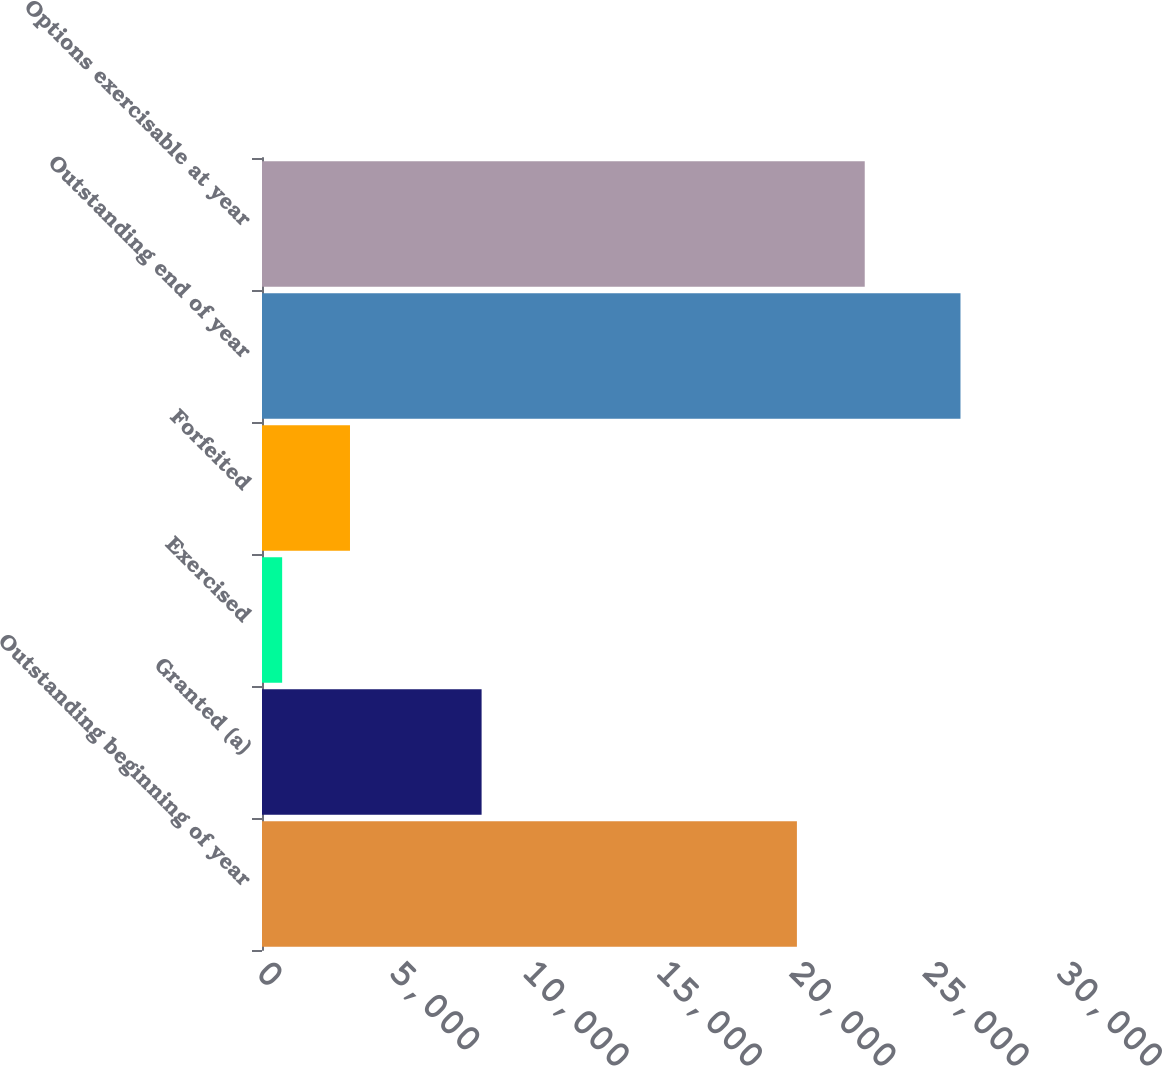Convert chart to OTSL. <chart><loc_0><loc_0><loc_500><loc_500><bar_chart><fcel>Outstanding beginning of year<fcel>Granted (a)<fcel>Exercised<fcel>Forfeited<fcel>Outstanding end of year<fcel>Options exercisable at year<nl><fcel>20059<fcel>8235<fcel>756<fcel>3299.7<fcel>26193<fcel>22602.7<nl></chart> 